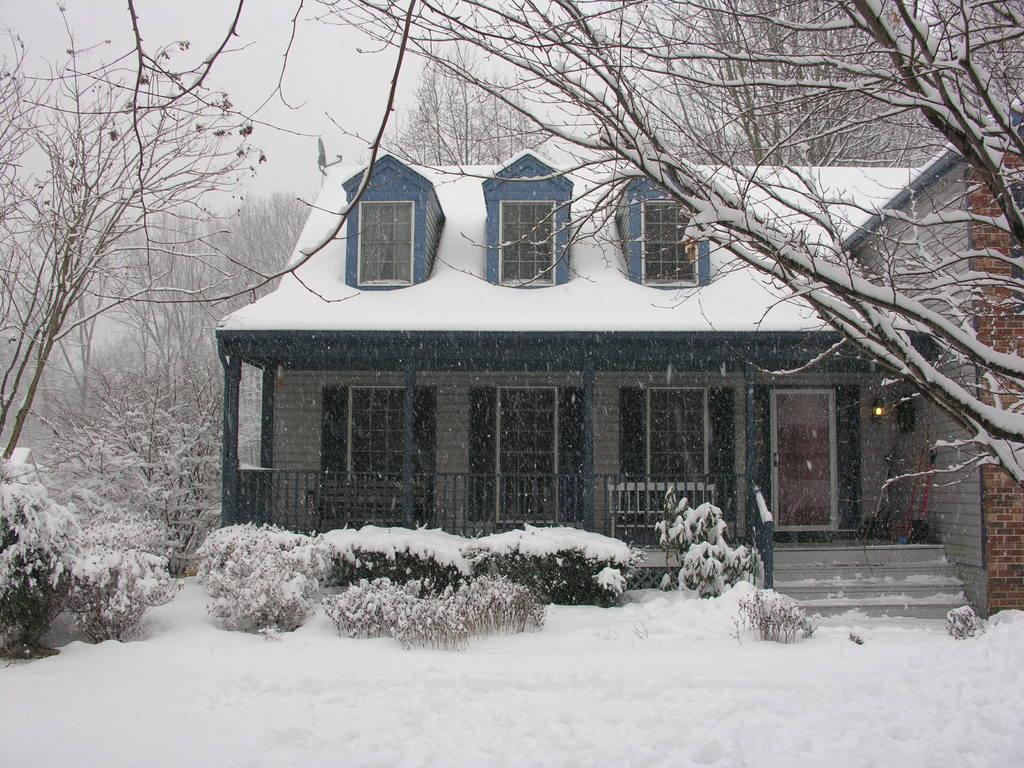What type of structure is visible in the image? There is a house in the image. What feature can be seen near the house? There is railing in the image. What is the weather condition in the image? There is snow in the image, indicating a cold or wintery setting. What type of vegetation is present in the image? There are plants and trees in the image. What part of the natural environment is visible in the image? The sky is visible in the image. What type of cable can be seen hanging from the trees in the image? There is no cable visible in the image; it only features a house, railing, snow, plants, trees, and the sky. 